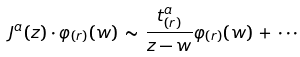Convert formula to latex. <formula><loc_0><loc_0><loc_500><loc_500>J ^ { a } ( z ) \cdot \varphi _ { ( r ) } ( w ) \, \sim \, \frac { t ^ { a } _ { ( r ) } } { z - w } \varphi _ { ( r ) } ( w ) \, + \, \cdots</formula> 